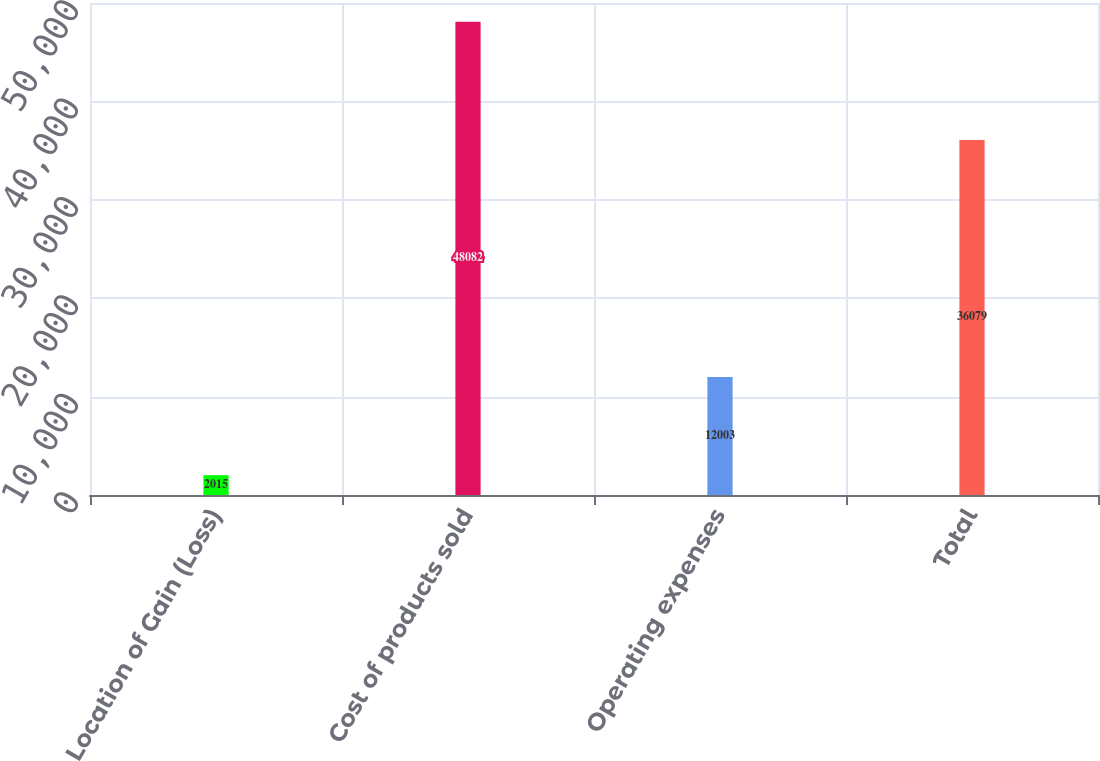Convert chart to OTSL. <chart><loc_0><loc_0><loc_500><loc_500><bar_chart><fcel>Location of Gain (Loss)<fcel>Cost of products sold<fcel>Operating expenses<fcel>Total<nl><fcel>2015<fcel>48082<fcel>12003<fcel>36079<nl></chart> 